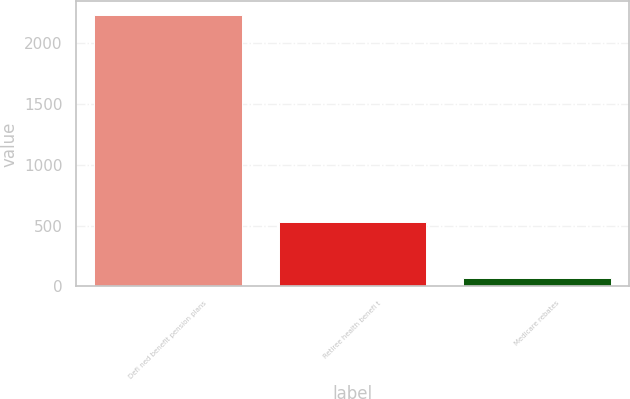Convert chart to OTSL. <chart><loc_0><loc_0><loc_500><loc_500><bar_chart><fcel>Defi ned benefit pension plans<fcel>Retiree health benefi t<fcel>Medicare rebates<nl><fcel>2234<fcel>530<fcel>69<nl></chart> 